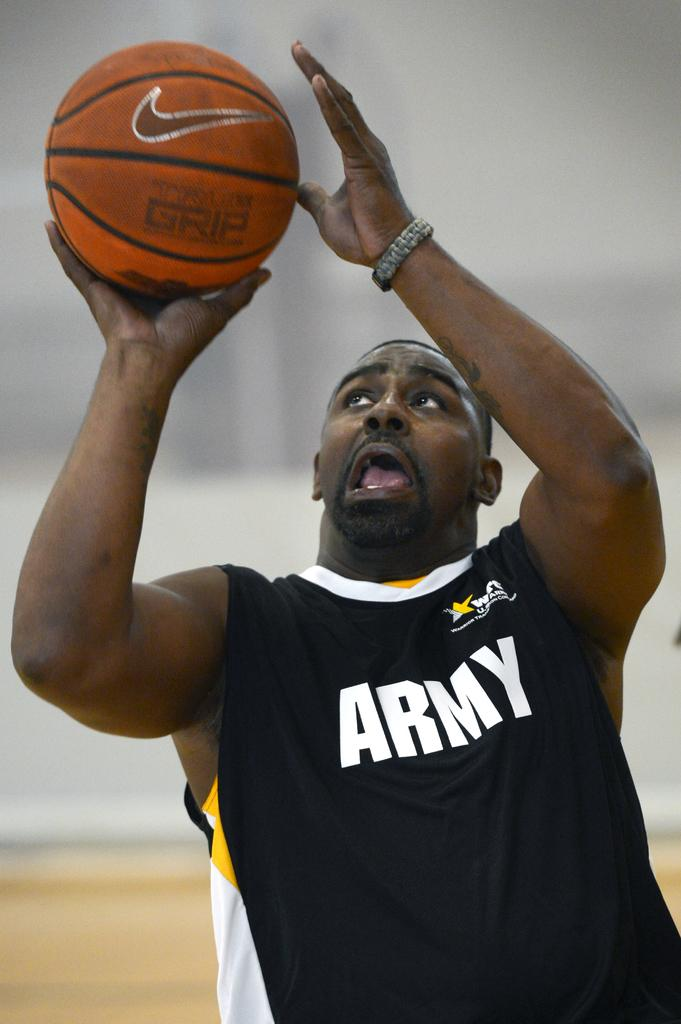<image>
Relay a brief, clear account of the picture shown. A basketball player in a black shirt with the word ARMY on it 